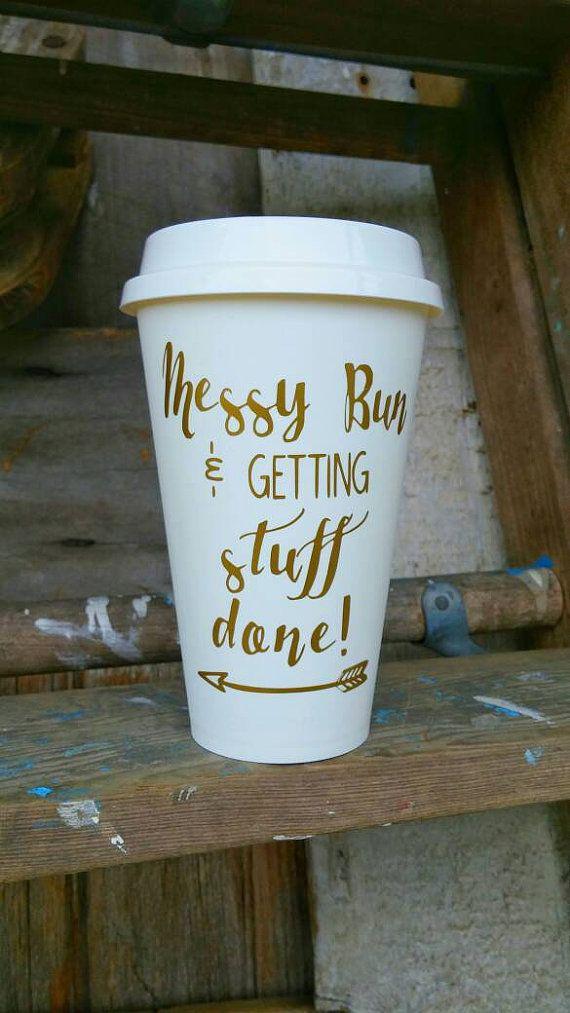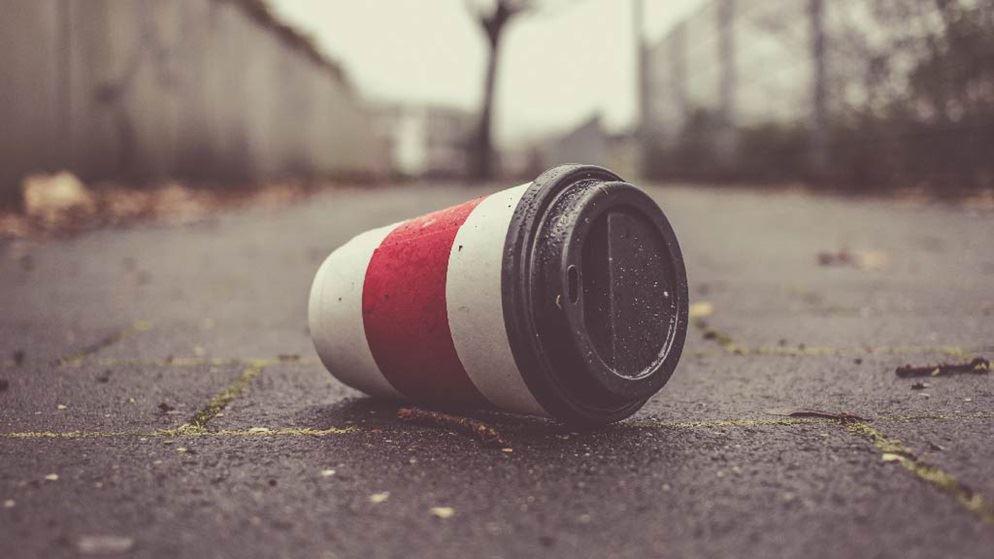The first image is the image on the left, the second image is the image on the right. For the images shown, is this caption "There are exactly two cups." true? Answer yes or no. Yes. The first image is the image on the left, the second image is the image on the right. Examine the images to the left and right. Is the description "There are only two disposable coffee cups." accurate? Answer yes or no. Yes. 